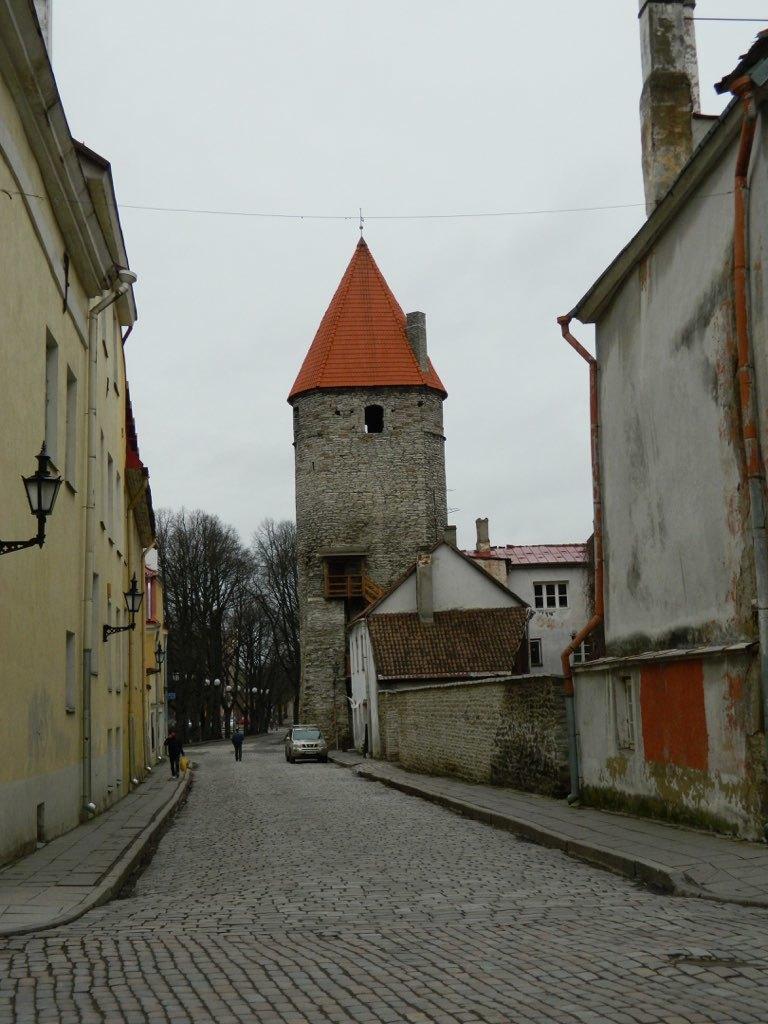How would you summarize this image in a sentence or two? In this image, we can see two persons in between roof houses. There are some trees in the middle of the image. There are is car on the road. There is a light on the left side of the image. At the top of the image, we can see the sky. 